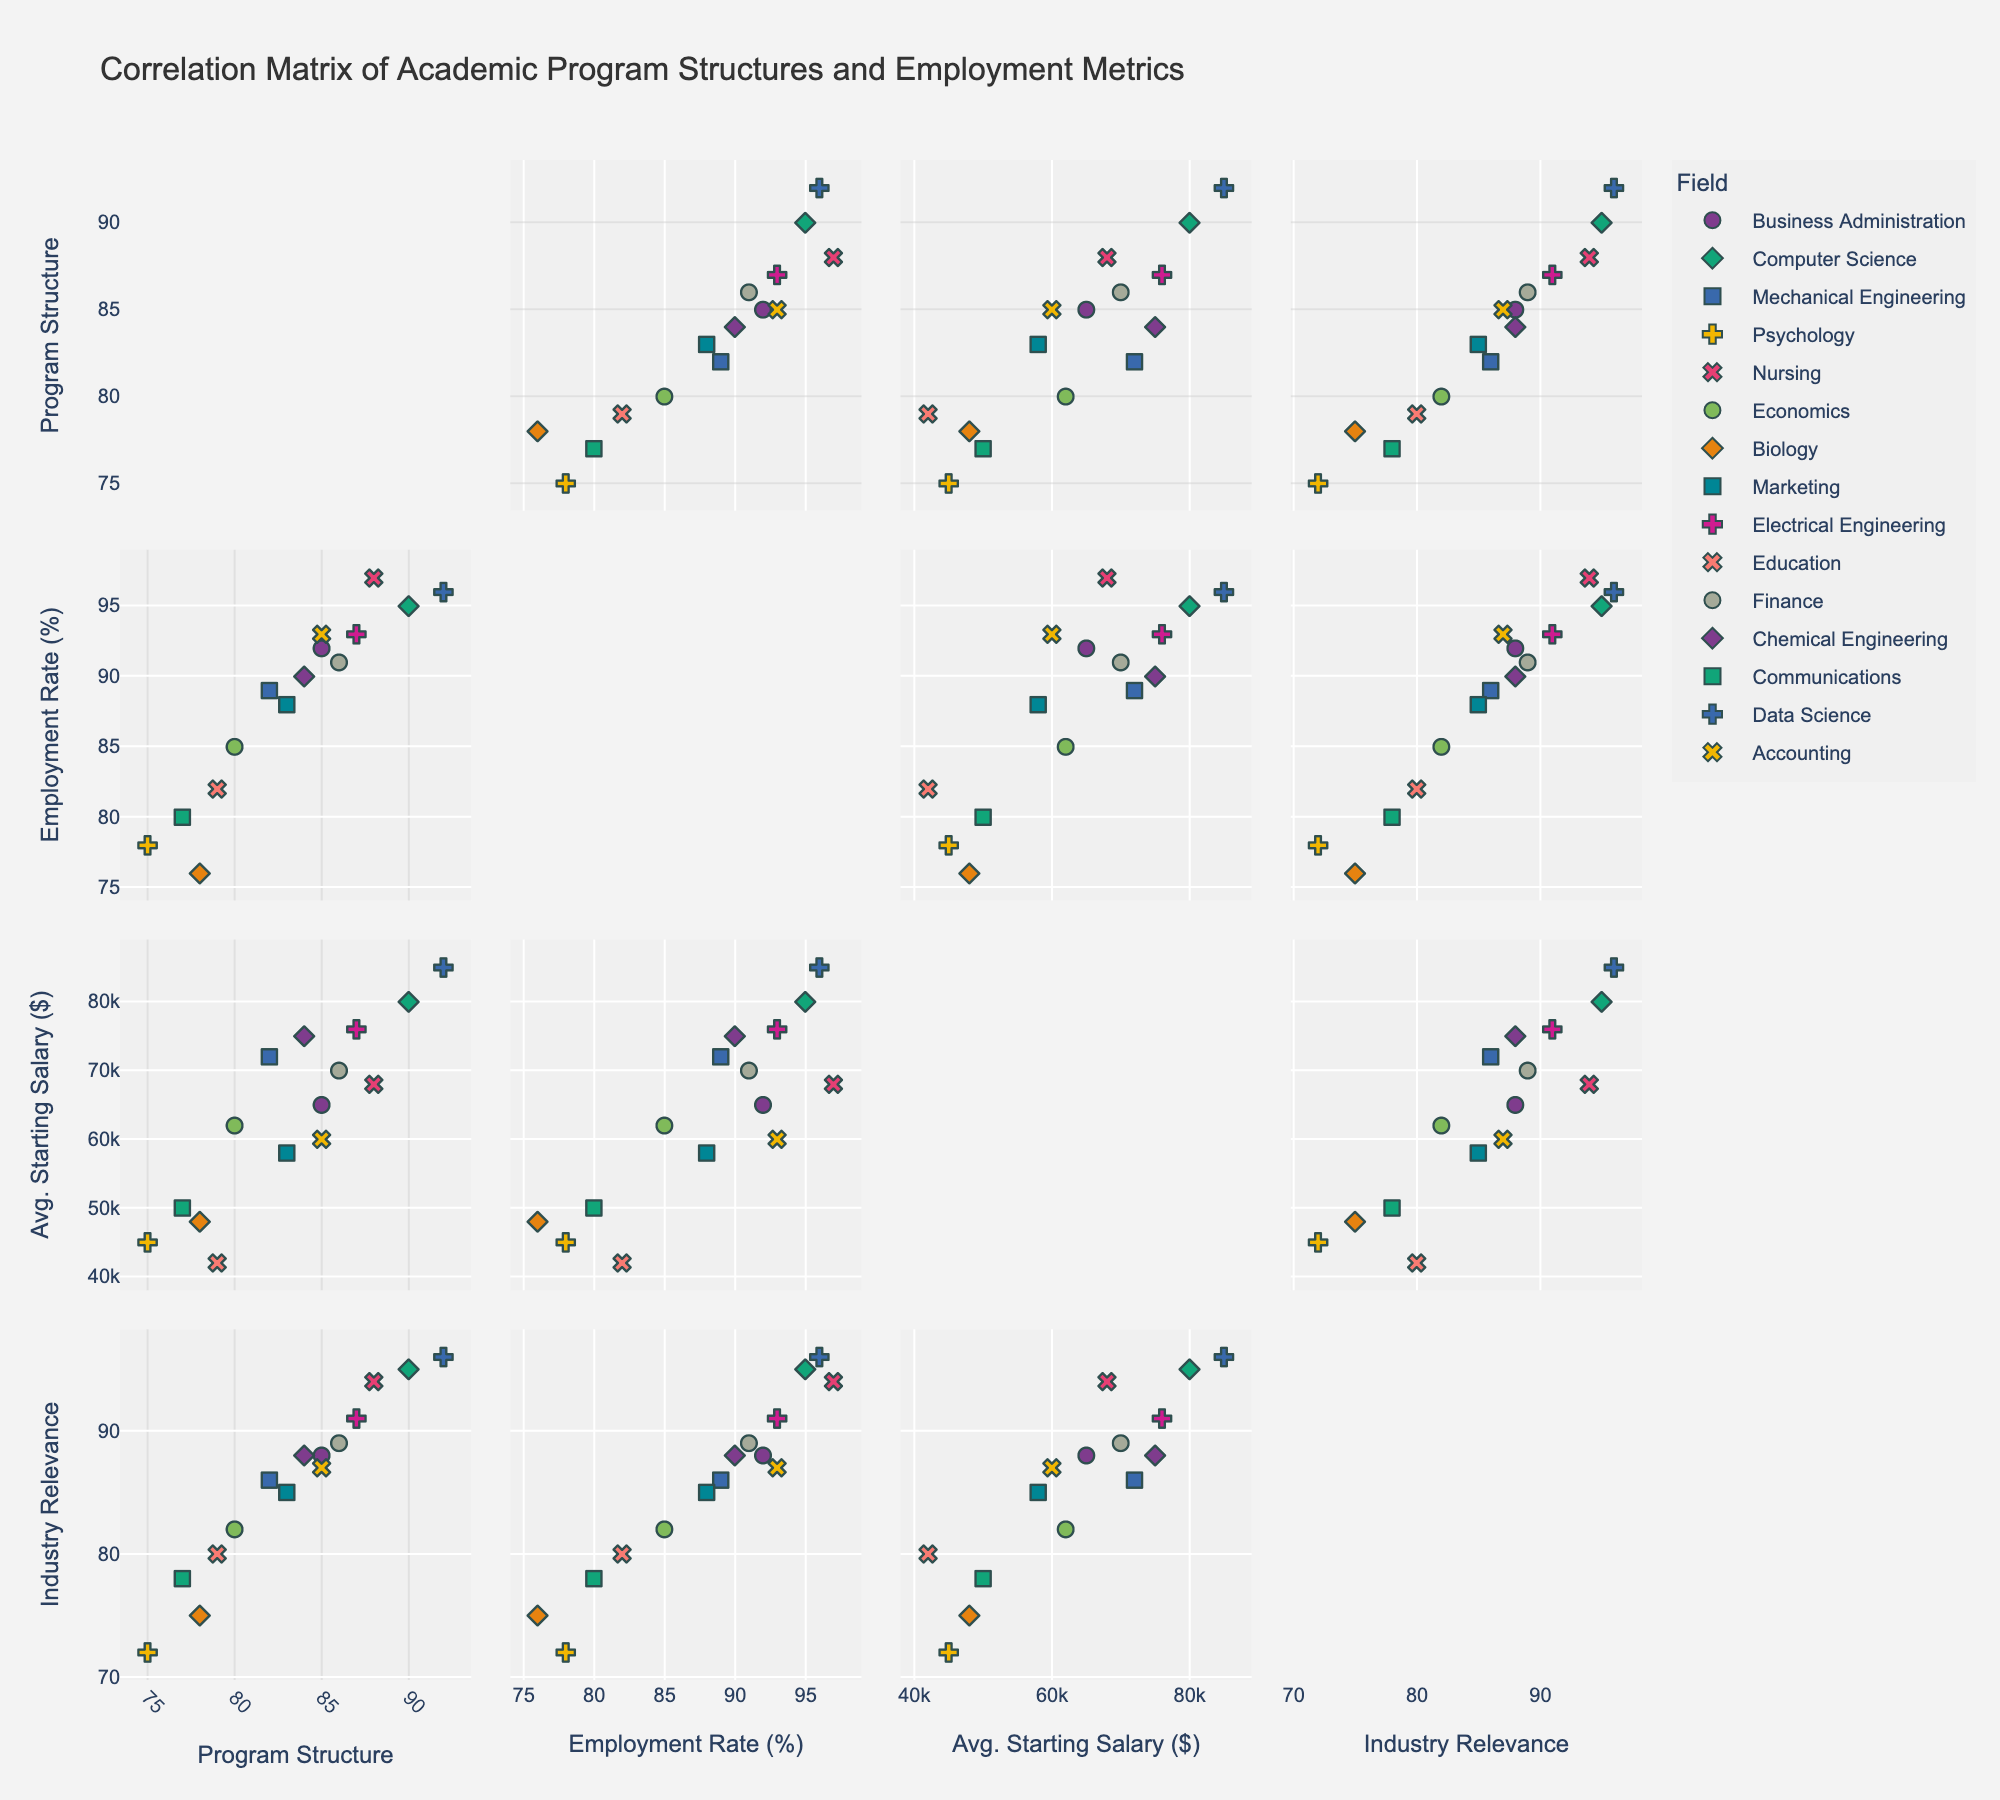What is the title of the figure? The title of the figure is displayed prominently at the top.
Answer: Correlation Matrix of Academic Program Structures and Employment Metrics Which field has the highest average starting salary? By examining the vertical position of the 'Avg. Starting Salary' scatter points, we can identify which field has the highest value.
Answer: Data Science What is the range of the Program Structure Scores represented in the scatter plot matrix? By looking at the axes labeled 'Program Structure', we can determine the minimum and maximum scores.
Answer: 75 to 92 Which field has the lowest employment rate? By examining the vertical position of the 'Employment Rate' scatter points, we can identify which field has the lowest value.
Answer: Biology What is the overall trend between Program Structure Scores and Employment Rate? By observing the scatter plots comparing 'Program Structure' and 'Employment Rate', we can identify if there's a positive, negative, or no correlation.
Answer: Positive correlation Among Business Administration, Nursing, and Data Science, which field has the highest Industry Relevance Score? Compare the 'Industry Relevance Score' scatter points along the vertical axis for each of these fields.
Answer: Data Science Is there a stronger correlation between Employment Rate and Avg. Starting Salary, or Employment Rate and Industry Relevance Score? Compare the scatter plot densities and the alignment of data points between Employment Rate with Avg. Starting Salary and Industry Relevance Score.
Answer: Employment Rate and Industry Relevance Score Are there any fields that have overlapping symbols in most of the scatter plots? Check scatter plots for consistently overlapping data points for any specific fields.
Answer: No significant overlaps Which field shows a relatively low Program Structure Score but high Employment Rate? Identify fields close to the bottom of 'Program Structure' and the top of 'Employment Rate' scatter points.
Answer: Nursing What pattern can be observed between Avg. Starting Salary and Industry Relevance Score? Observe the scatter plot comparing 'Avg. Starting Salary' and 'Industry Relevance Score' for any trends or patterns.
Answer: Positive trend 